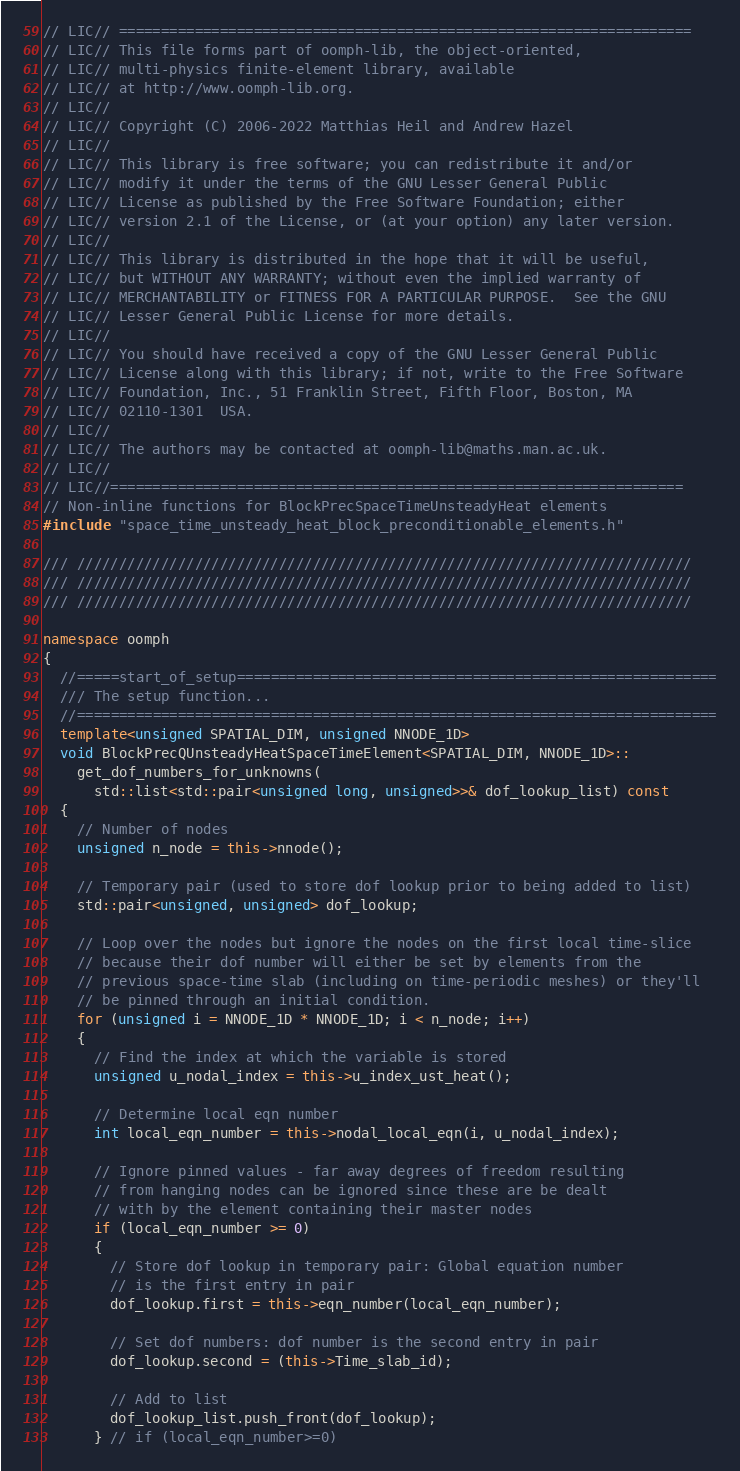Convert code to text. <code><loc_0><loc_0><loc_500><loc_500><_C++_>// LIC// ====================================================================
// LIC// This file forms part of oomph-lib, the object-oriented,
// LIC// multi-physics finite-element library, available
// LIC// at http://www.oomph-lib.org.
// LIC//
// LIC// Copyright (C) 2006-2022 Matthias Heil and Andrew Hazel
// LIC//
// LIC// This library is free software; you can redistribute it and/or
// LIC// modify it under the terms of the GNU Lesser General Public
// LIC// License as published by the Free Software Foundation; either
// LIC// version 2.1 of the License, or (at your option) any later version.
// LIC//
// LIC// This library is distributed in the hope that it will be useful,
// LIC// but WITHOUT ANY WARRANTY; without even the implied warranty of
// LIC// MERCHANTABILITY or FITNESS FOR A PARTICULAR PURPOSE.  See the GNU
// LIC// Lesser General Public License for more details.
// LIC//
// LIC// You should have received a copy of the GNU Lesser General Public
// LIC// License along with this library; if not, write to the Free Software
// LIC// Foundation, Inc., 51 Franklin Street, Fifth Floor, Boston, MA
// LIC// 02110-1301  USA.
// LIC//
// LIC// The authors may be contacted at oomph-lib@maths.man.ac.uk.
// LIC//
// LIC//====================================================================
// Non-inline functions for BlockPrecSpaceTimeUnsteadyHeat elements
#include "space_time_unsteady_heat_block_preconditionable_elements.h"

/// /////////////////////////////////////////////////////////////////////////
/// /////////////////////////////////////////////////////////////////////////
/// /////////////////////////////////////////////////////////////////////////

namespace oomph
{
  //=====start_of_setup=========================================================
  /// The setup function...
  //============================================================================
  template<unsigned SPATIAL_DIM, unsigned NNODE_1D>
  void BlockPrecQUnsteadyHeatSpaceTimeElement<SPATIAL_DIM, NNODE_1D>::
    get_dof_numbers_for_unknowns(
      std::list<std::pair<unsigned long, unsigned>>& dof_lookup_list) const
  {
    // Number of nodes
    unsigned n_node = this->nnode();

    // Temporary pair (used to store dof lookup prior to being added to list)
    std::pair<unsigned, unsigned> dof_lookup;

    // Loop over the nodes but ignore the nodes on the first local time-slice
    // because their dof number will either be set by elements from the
    // previous space-time slab (including on time-periodic meshes) or they'll
    // be pinned through an initial condition.
    for (unsigned i = NNODE_1D * NNODE_1D; i < n_node; i++)
    {
      // Find the index at which the variable is stored
      unsigned u_nodal_index = this->u_index_ust_heat();

      // Determine local eqn number
      int local_eqn_number = this->nodal_local_eqn(i, u_nodal_index);

      // Ignore pinned values - far away degrees of freedom resulting
      // from hanging nodes can be ignored since these are be dealt
      // with by the element containing their master nodes
      if (local_eqn_number >= 0)
      {
        // Store dof lookup in temporary pair: Global equation number
        // is the first entry in pair
        dof_lookup.first = this->eqn_number(local_eqn_number);

        // Set dof numbers: dof number is the second entry in pair
        dof_lookup.second = (this->Time_slab_id);

        // Add to list
        dof_lookup_list.push_front(dof_lookup);
      } // if (local_eqn_number>=0)</code> 